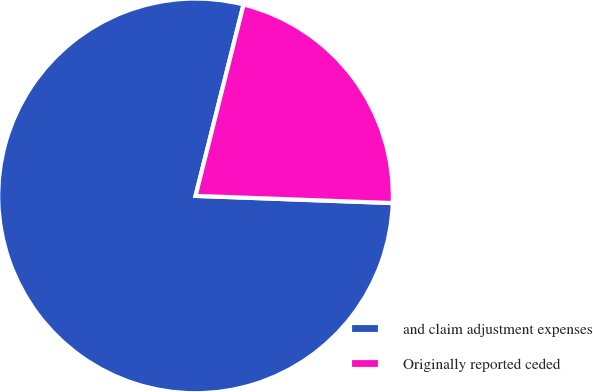Convert chart to OTSL. <chart><loc_0><loc_0><loc_500><loc_500><pie_chart><fcel>and claim adjustment expenses<fcel>Originally reported ceded<nl><fcel>78.33%<fcel>21.67%<nl></chart> 